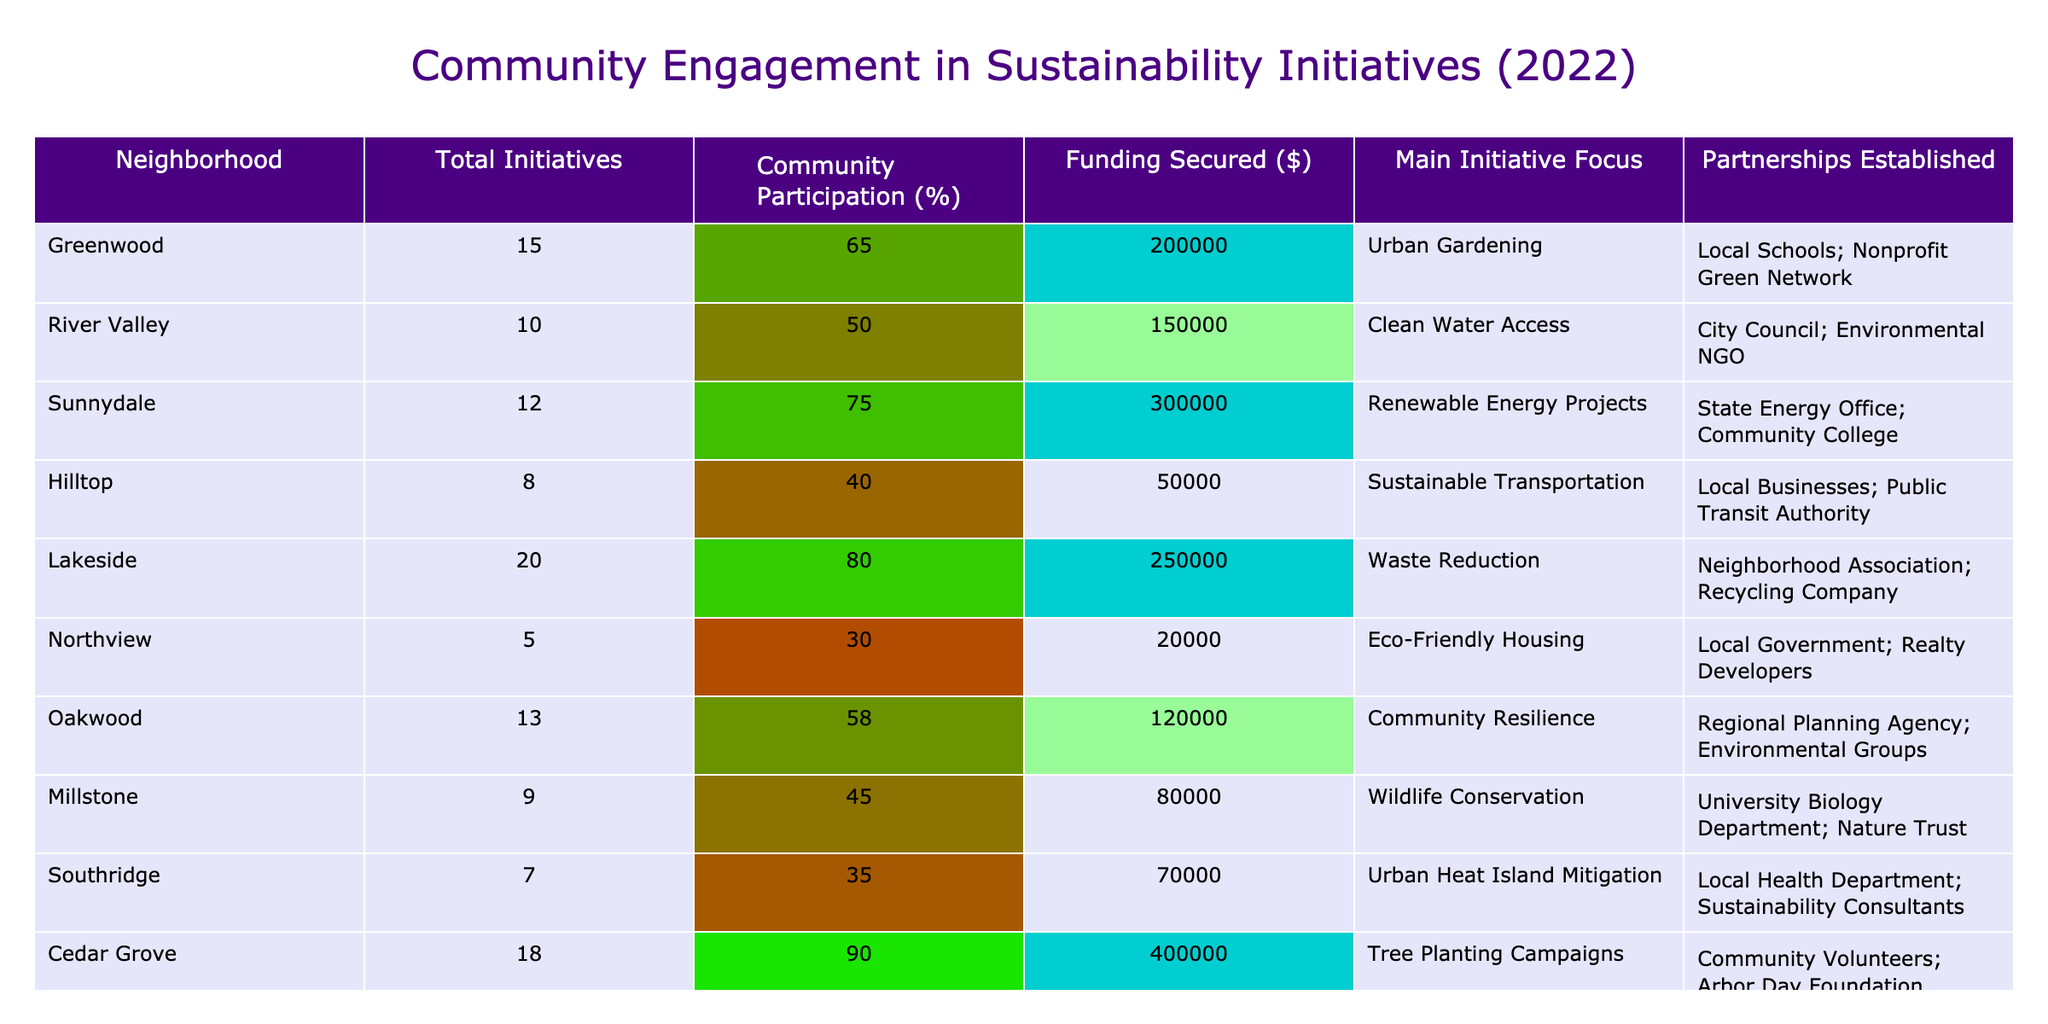What neighborhood had the highest community participation percentage? Looking at the Community Participation (%) column, Cedar Grove has the highest value at 90%.
Answer: Cedar Grove Which neighborhood secured the least funding for sustainability initiatives? By examining the Funding Secured ($) column, Northview has the lowest figure at $20,000.
Answer: Northview What is the average community participation percentage across all neighborhoods? Adding all the participation percentages gives 65 + 50 + 75 + 40 + 80 + 30 + 58 + 45 + 35 + 90 =  718. Dividing by the number of neighborhoods (10) results in an average of 71.8%.
Answer: 71.8% Did any neighborhood establish partnerships with local businesses? Hilltop is the only neighborhood that lists local businesses as a partnership in its initiatives.
Answer: Yes Which neighborhood had both the highest funding secured and community participation? Cedar Grove had the highest funding of $400,000 and also the highest community participation at 90%, indicating it led in both categories.
Answer: Cedar Grove How much total funding was secured by neighborhoods with a participation rate below 50%? Adding the funding for Northview ($20,000) and Southridge ($70,000) results in a total of $90,000 for neighborhoods with less than 50% participation.
Answer: $90,000 What was the focus of the initiative in the neighborhood that had the most initiatives? Greenwood had the most initiatives, totaling 15, and its main focus was on Urban Gardening.
Answer: Urban Gardening Are there any neighborhoods where the funding secured is greater than $200,000 and community participation is below 60%? By checking the table, no neighborhood has both a funding level above $200,000 and a community participation rate below 60%.
Answer: No Which neighborhood saw a focus on renewable energy projects? Sunnydale is the neighborhood focused on Renewable Energy Projects, as indicated in the Main Initiative Focus column.
Answer: Sunnydale What is the difference in funding secured between the neighborhood with the most initiatives and the neighborhood with the least initiatives? Greenwood secured $200,000 and Northview secured $20,000, so the difference is $200,000 - $20,000 = $180,000.
Answer: $180,000 